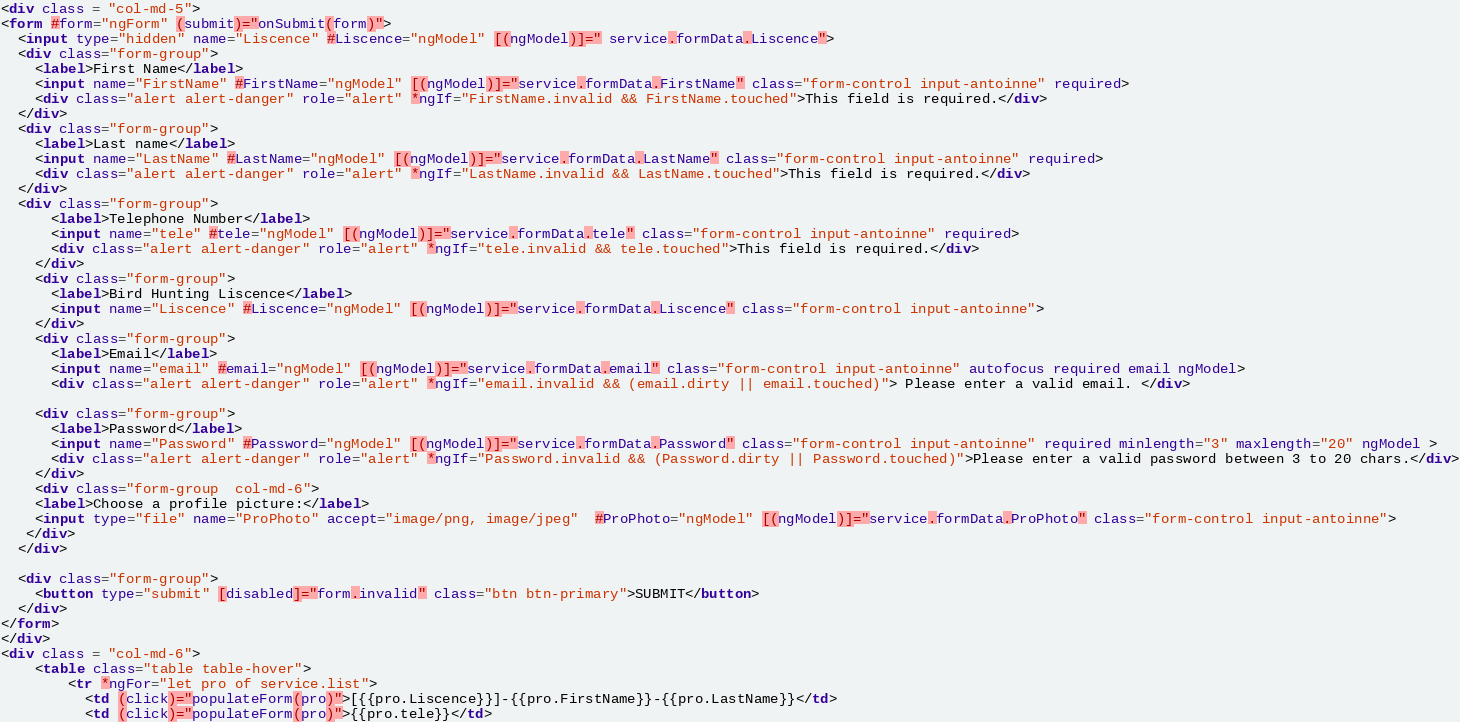Convert code to text. <code><loc_0><loc_0><loc_500><loc_500><_HTML_><div class = "col-md-5">
<form #form="ngForm" (submit)="onSubmit(form)">
  <input type="hidden" name="Liscence" #Liscence="ngModel" [(ngModel)]=" service.formData.Liscence">
  <div class="form-group">
    <label>First Name</label>
    <input name="FirstName" #FirstName="ngModel" [(ngModel)]="service.formData.FirstName" class="form-control input-antoinne" required>
    <div class="alert alert-danger" role="alert" *ngIf="FirstName.invalid && FirstName.touched">This field is required.</div>
  </div>
  <div class="form-group">
    <label>Last name</label>
    <input name="LastName" #LastName="ngModel" [(ngModel)]="service.formData.LastName" class="form-control input-antoinne" required>
    <div class="alert alert-danger" role="alert" *ngIf="LastName.invalid && LastName.touched">This field is required.</div>
  </div>
  <div class="form-group">
      <label>Telephone Number</label>
      <input name="tele" #tele="ngModel" [(ngModel)]="service.formData.tele" class="form-control input-antoinne" required>
      <div class="alert alert-danger" role="alert" *ngIf="tele.invalid && tele.touched">This field is required.</div>
    </div>
    <div class="form-group">
      <label>Bird Hunting Liscence</label>
      <input name="Liscence" #Liscence="ngModel" [(ngModel)]="service.formData.Liscence" class="form-control input-antoinne">
    </div>
    <div class="form-group">
      <label>Email</label>
      <input name="email" #email="ngModel" [(ngModel)]="service.formData.email" class="form-control input-antoinne" autofocus required email ngModel>
      <div class="alert alert-danger" role="alert" *ngIf="email.invalid && (email.dirty || email.touched)"> Please enter a valid email. </div>
    
    <div class="form-group">
      <label>Password</label>
      <input name="Password" #Password="ngModel" [(ngModel)]="service.formData.Password" class="form-control input-antoinne" required minlength="3" maxlength="20" ngModel >
      <div class="alert alert-danger" role="alert" *ngIf="Password.invalid && (Password.dirty || Password.touched)">Please enter a valid password between 3 to 20 chars.</div>
    </div>
    <div class="form-group  col-md-6">
    <label>Choose a profile picture:</label>
    <input type="file" name="ProPhoto" accept="image/png, image/jpeg"  #ProPhoto="ngModel" [(ngModel)]="service.formData.ProPhoto" class="form-control input-antoinne">
   </div>
  </div>
  
  <div class="form-group">
    <button type="submit" [disabled]="form.invalid" class="btn btn-primary">SUBMIT</button>
  </div>
</form>
</div>
<div class = "col-md-6">
    <table class="table table-hover">
        <tr *ngFor="let pro of service.list">
          <td (click)="populateForm(pro)">[{{pro.Liscence}}]-{{pro.FirstName}}-{{pro.LastName}}</td>
          <td (click)="populateForm(pro)">{{pro.tele}}</td></code> 